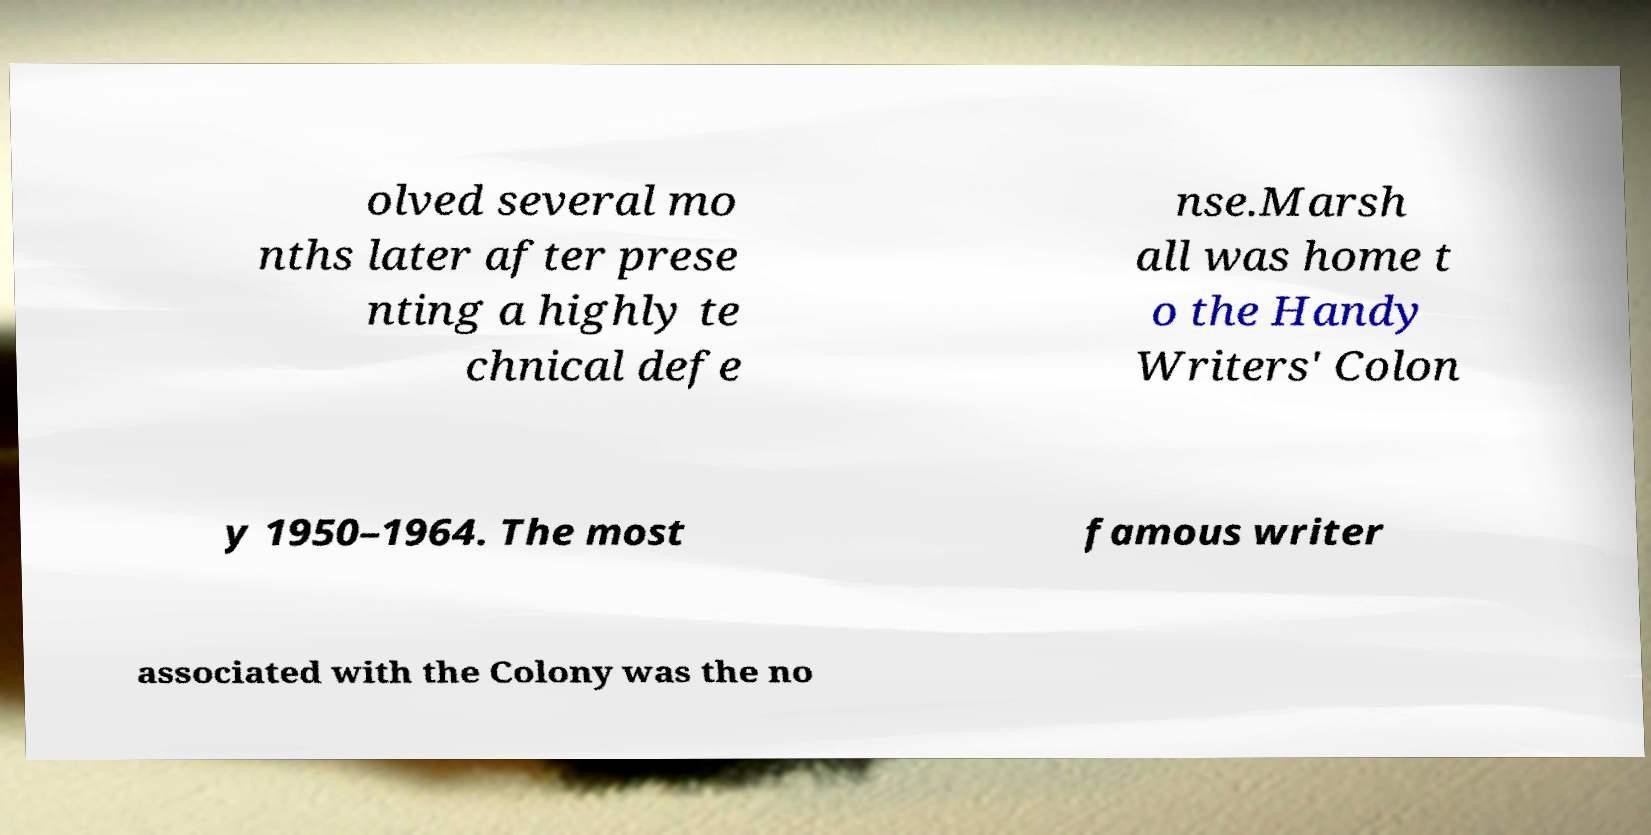Please read and relay the text visible in this image. What does it say? olved several mo nths later after prese nting a highly te chnical defe nse.Marsh all was home t o the Handy Writers' Colon y 1950–1964. The most famous writer associated with the Colony was the no 